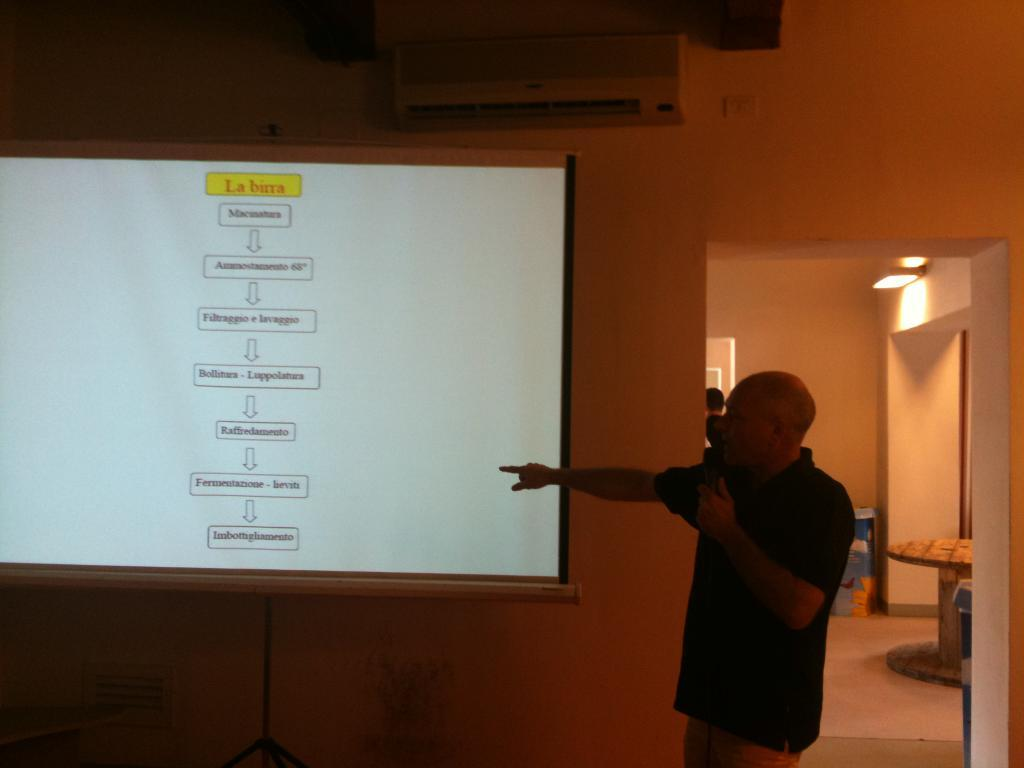Provide a one-sentence caption for the provided image. The power point is in a language that is not English. 